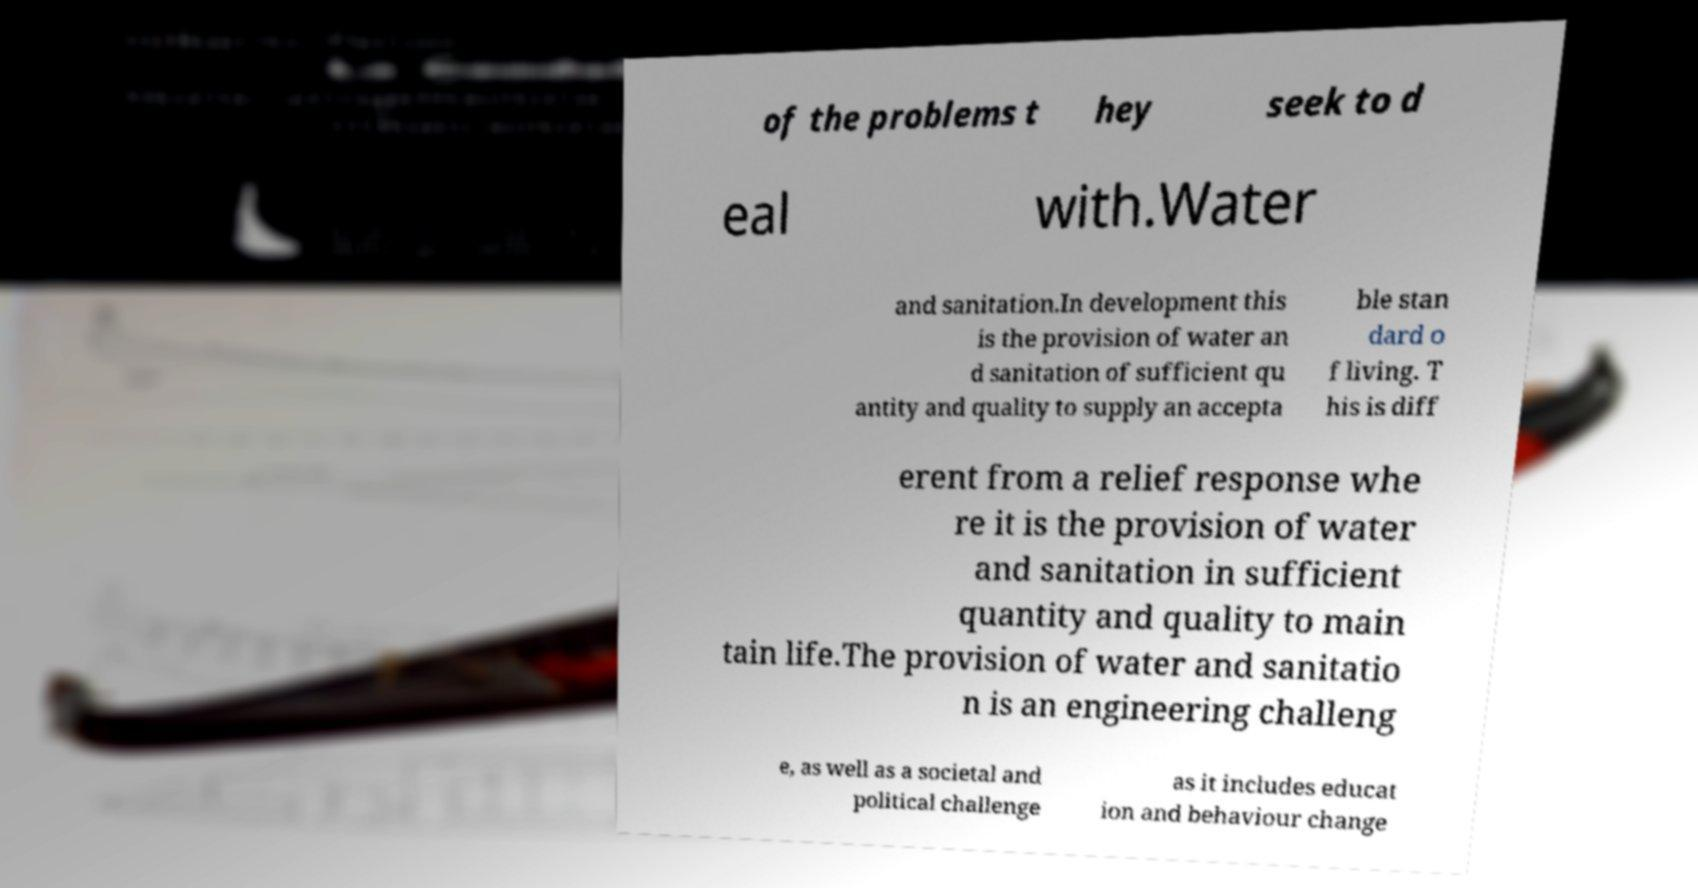For documentation purposes, I need the text within this image transcribed. Could you provide that? of the problems t hey seek to d eal with.Water and sanitation.In development this is the provision of water an d sanitation of sufficient qu antity and quality to supply an accepta ble stan dard o f living. T his is diff erent from a relief response whe re it is the provision of water and sanitation in sufficient quantity and quality to main tain life.The provision of water and sanitatio n is an engineering challeng e, as well as a societal and political challenge as it includes educat ion and behaviour change 